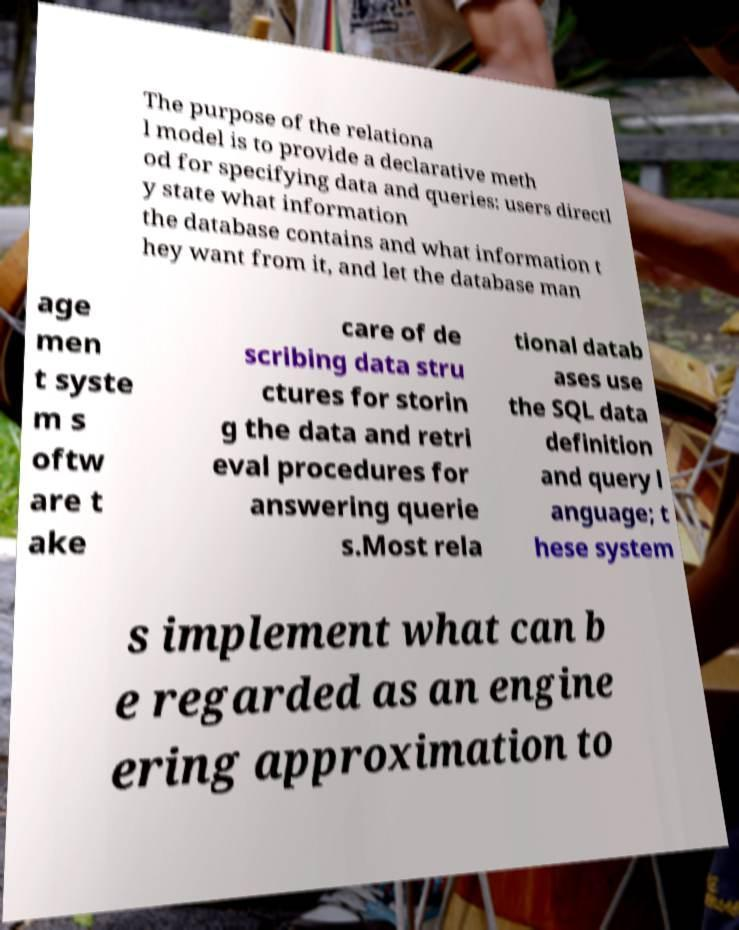Could you extract and type out the text from this image? The purpose of the relationa l model is to provide a declarative meth od for specifying data and queries: users directl y state what information the database contains and what information t hey want from it, and let the database man age men t syste m s oftw are t ake care of de scribing data stru ctures for storin g the data and retri eval procedures for answering querie s.Most rela tional datab ases use the SQL data definition and query l anguage; t hese system s implement what can b e regarded as an engine ering approximation to 